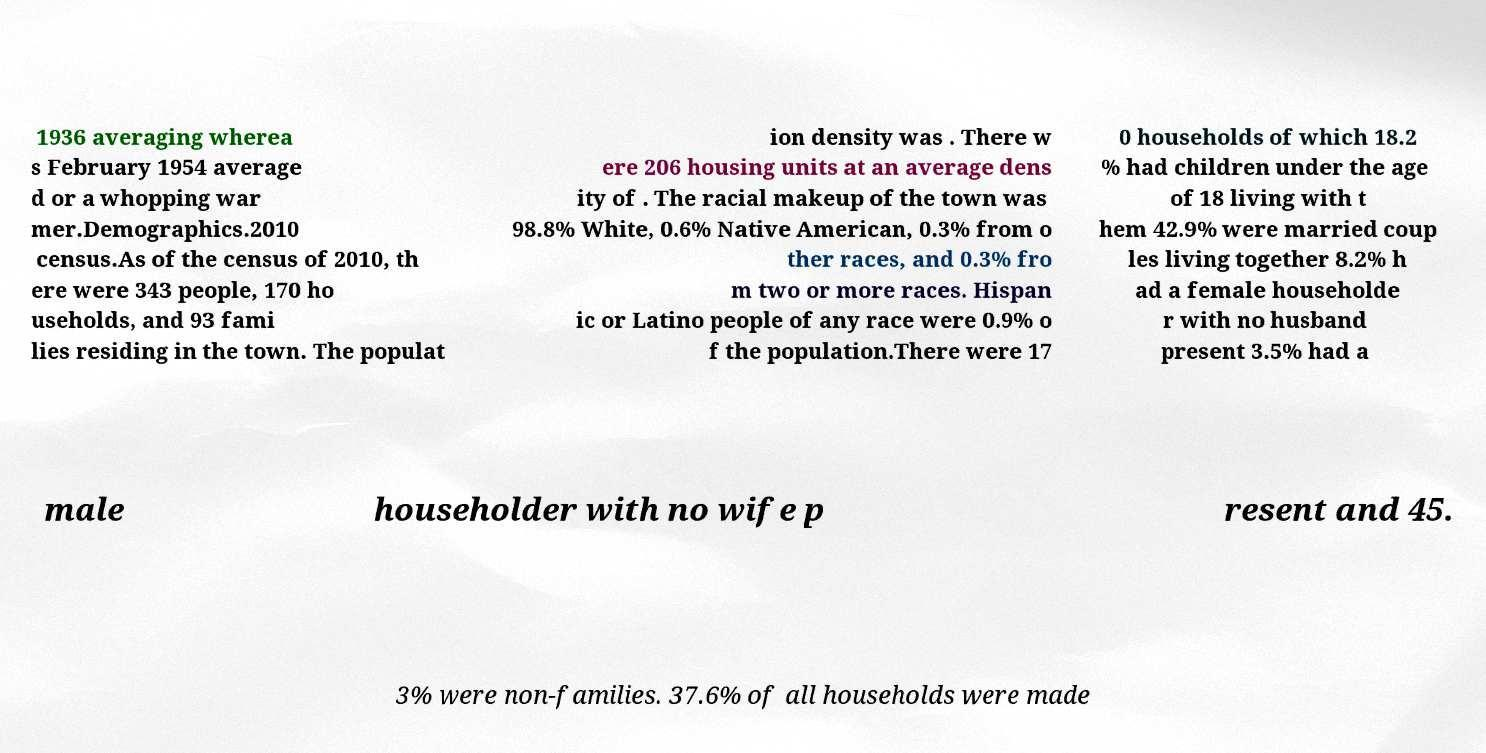There's text embedded in this image that I need extracted. Can you transcribe it verbatim? 1936 averaging wherea s February 1954 average d or a whopping war mer.Demographics.2010 census.As of the census of 2010, th ere were 343 people, 170 ho useholds, and 93 fami lies residing in the town. The populat ion density was . There w ere 206 housing units at an average dens ity of . The racial makeup of the town was 98.8% White, 0.6% Native American, 0.3% from o ther races, and 0.3% fro m two or more races. Hispan ic or Latino people of any race were 0.9% o f the population.There were 17 0 households of which 18.2 % had children under the age of 18 living with t hem 42.9% were married coup les living together 8.2% h ad a female householde r with no husband present 3.5% had a male householder with no wife p resent and 45. 3% were non-families. 37.6% of all households were made 